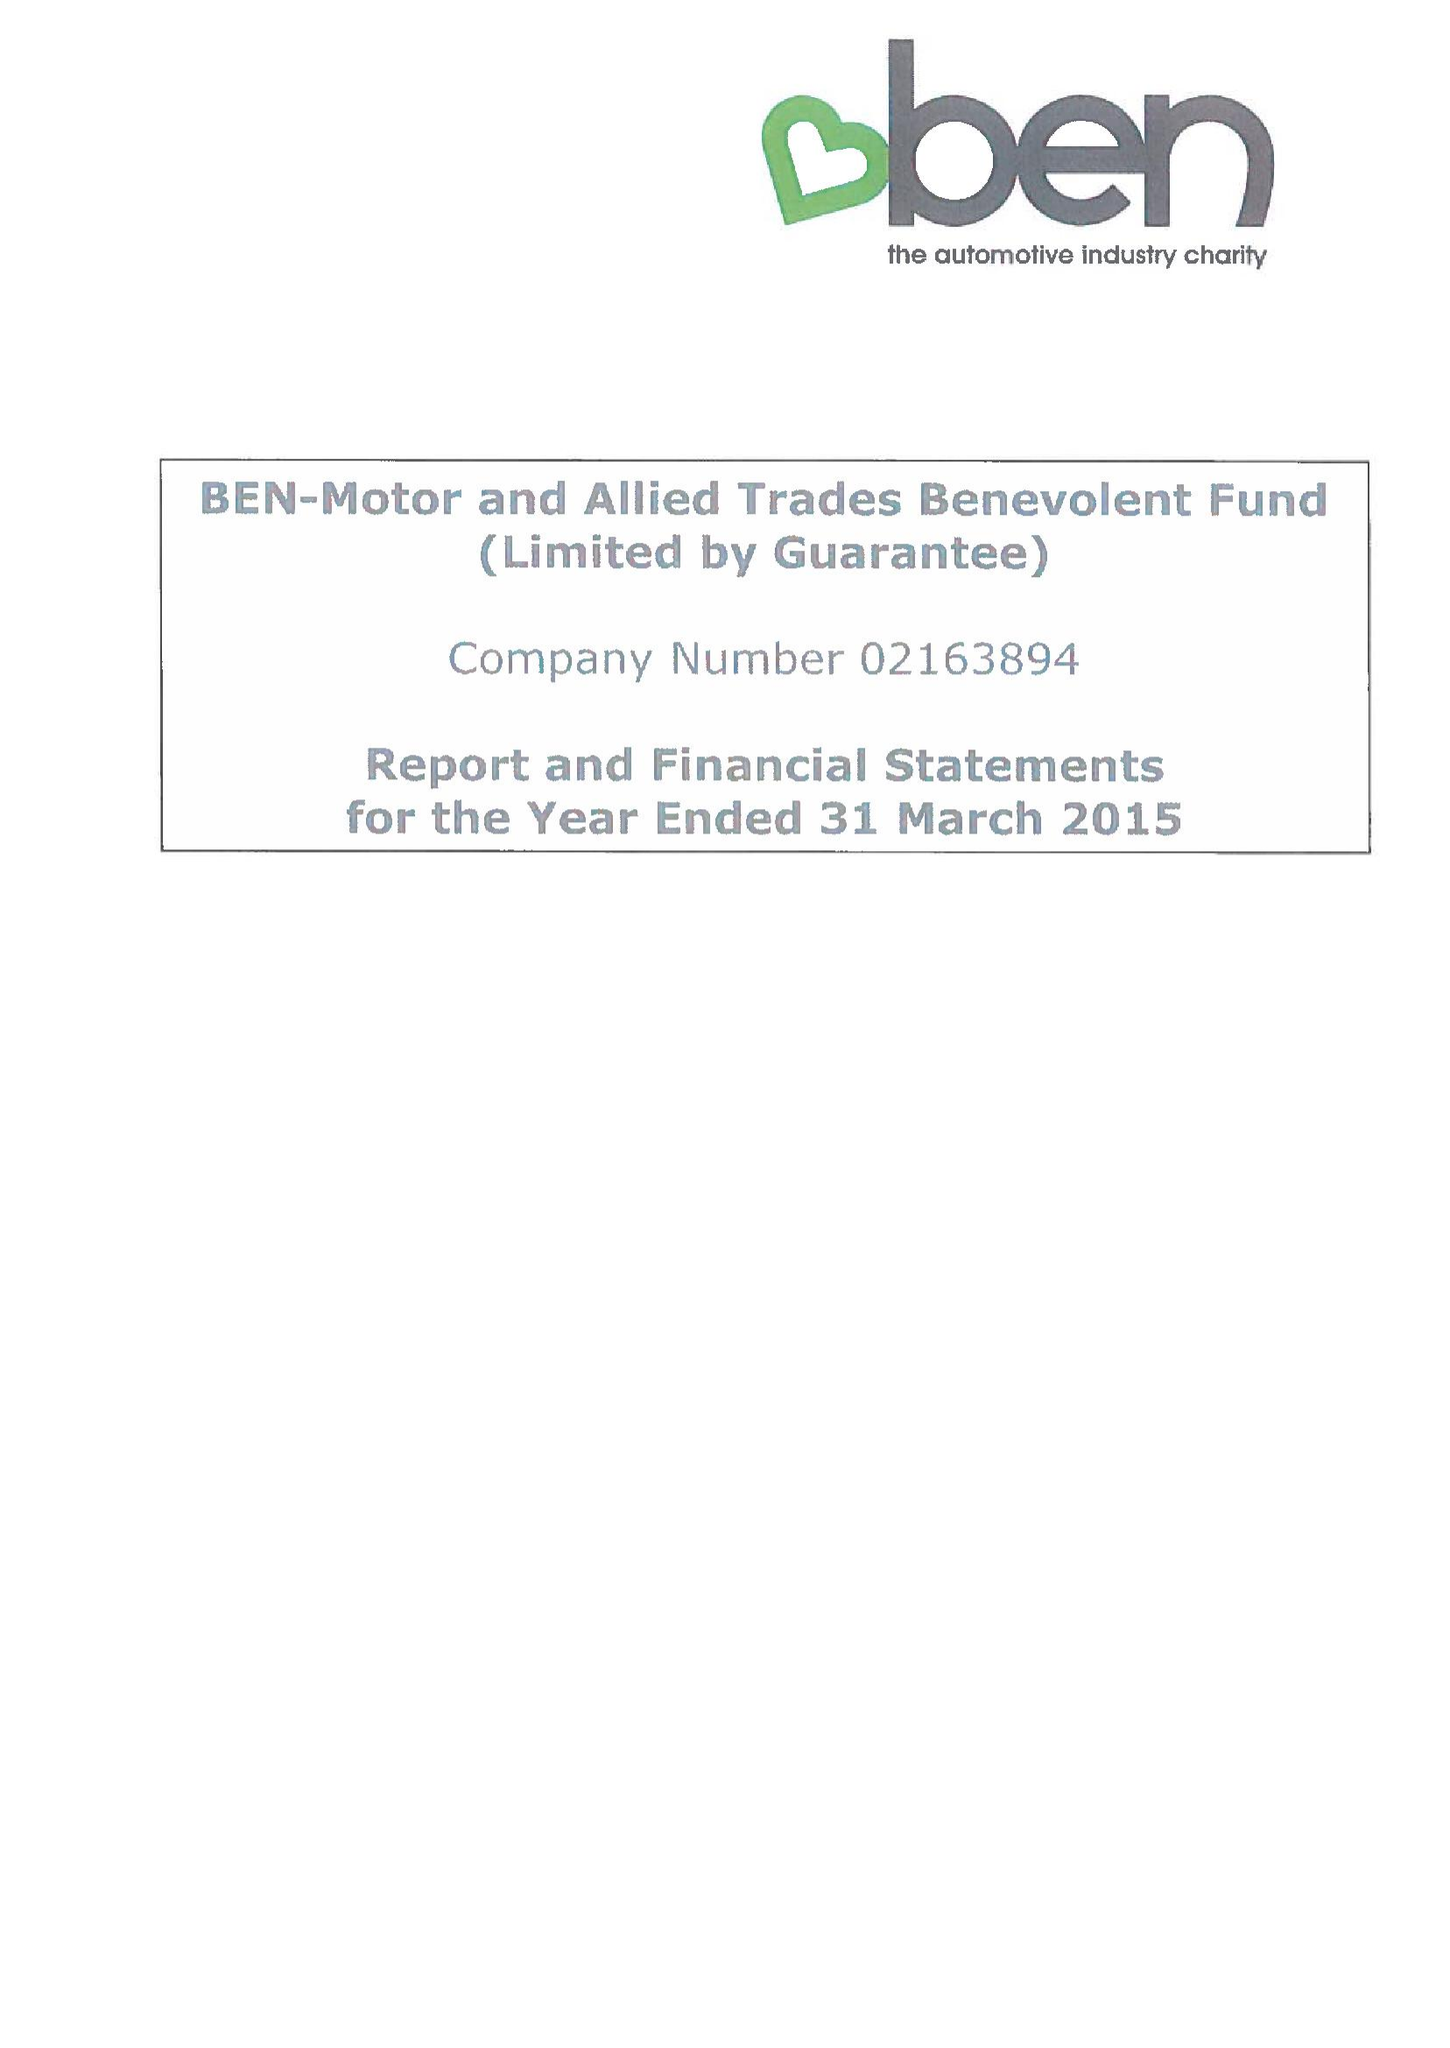What is the value for the charity_number?
Answer the question using a single word or phrase. 297877 